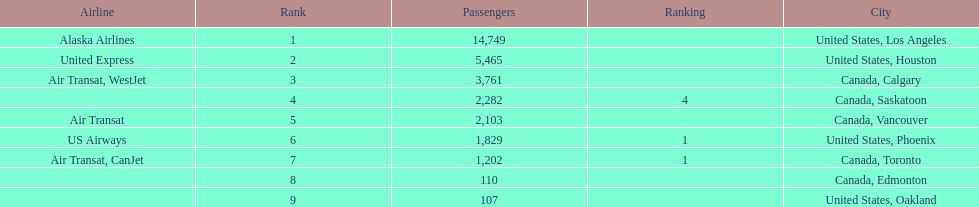How many more passengers flew to los angeles than to saskatoon from manzanillo airport in 2013? 12,467. 